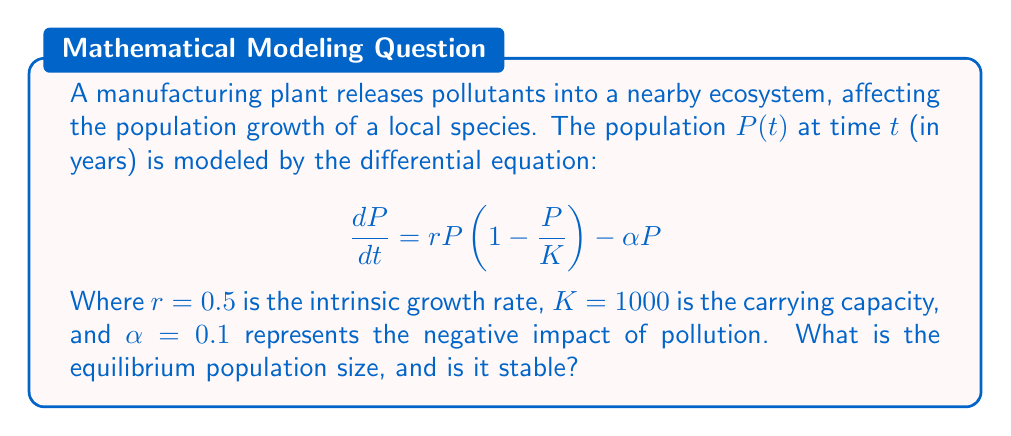Teach me how to tackle this problem. To find the equilibrium population size and determine its stability, we follow these steps:

1) Find the equilibrium points by setting $\frac{dP}{dt} = 0$:

   $$0 = rP\left(1 - \frac{P}{K}\right) - \alpha P$$

2) Factor out $P$:

   $$0 = P\left(r\left(1 - \frac{P}{K}\right) - \alpha\right)$$

3) Solve for $P$:
   
   $P = 0$ or $r\left(1 - \frac{P}{K}\right) - \alpha = 0$

4) For the non-zero equilibrium:

   $$r - \frac{rP}{K} - \alpha = 0$$
   $$r - \alpha = \frac{rP}{K}$$
   $$P = K\left(1 - \frac{\alpha}{r}\right)$$

5) Substitute the given values:

   $$P = 1000\left(1 - \frac{0.1}{0.5}\right) = 1000(0.8) = 800$$

6) To determine stability, evaluate $\frac{d}{dP}\left(\frac{dP}{dt}\right)$ at the equilibrium point:

   $$\frac{d}{dP}\left(\frac{dP}{dt}\right) = r - \frac{2rP}{K} - \alpha$$

7) At $P = 800$:

   $$\frac{d}{dP}\left(\frac{dP}{dt}\right) = 0.5 - \frac{2(0.5)(800)}{1000} - 0.1 = -0.5$$

8) Since this value is negative, the non-zero equilibrium is stable.
Answer: Stable equilibrium at $P = 800$ 